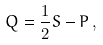Convert formula to latex. <formula><loc_0><loc_0><loc_500><loc_500>Q = \frac { 1 } { 2 } S - P \, ,</formula> 